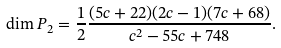Convert formula to latex. <formula><loc_0><loc_0><loc_500><loc_500>\dim P _ { 2 } = \frac { 1 } { 2 } \frac { ( 5 c + 2 2 ) ( 2 c - 1 ) ( 7 c + 6 8 ) } { c ^ { 2 } - 5 5 c + 7 4 8 } .</formula> 